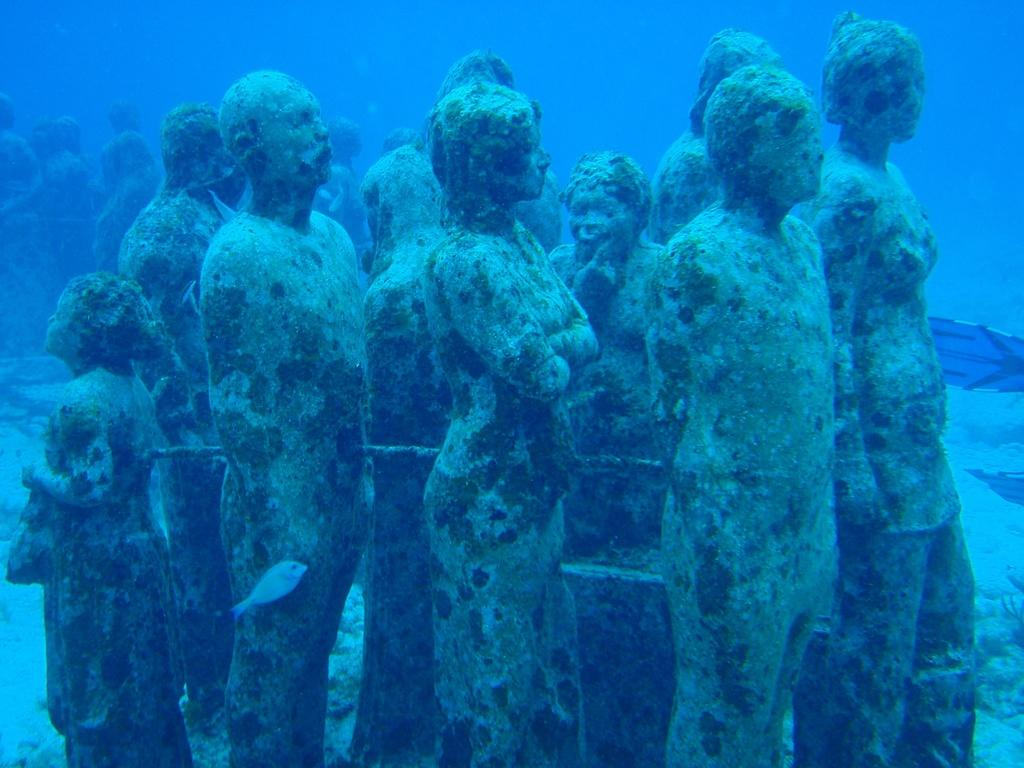What is located under the water in the image? There are statues under the water in the image. What type of animal can be seen in the image? There is a fish in the image. Can you describe any other objects in the image? There are a few objects in the image. Where is the fireman in the image? There is no fireman present in the image. What type of flame can be seen in the image? There is no flame present in the image. 